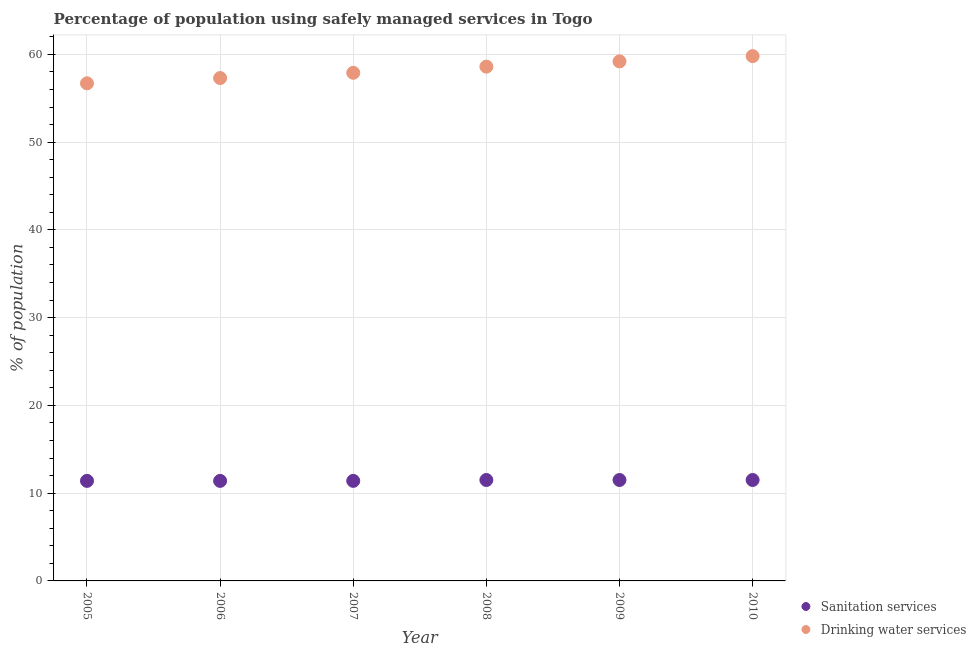Across all years, what is the minimum percentage of population who used drinking water services?
Ensure brevity in your answer.  56.7. In which year was the percentage of population who used sanitation services minimum?
Your response must be concise. 2005. What is the total percentage of population who used sanitation services in the graph?
Ensure brevity in your answer.  68.7. What is the difference between the percentage of population who used sanitation services in 2006 and that in 2009?
Keep it short and to the point. -0.1. What is the difference between the percentage of population who used sanitation services in 2010 and the percentage of population who used drinking water services in 2006?
Ensure brevity in your answer.  -45.8. What is the average percentage of population who used drinking water services per year?
Ensure brevity in your answer.  58.25. In the year 2009, what is the difference between the percentage of population who used sanitation services and percentage of population who used drinking water services?
Offer a terse response. -47.7. What is the ratio of the percentage of population who used sanitation services in 2009 to that in 2010?
Provide a short and direct response. 1. Is the percentage of population who used sanitation services in 2005 less than that in 2006?
Your answer should be compact. No. Is the difference between the percentage of population who used sanitation services in 2007 and 2009 greater than the difference between the percentage of population who used drinking water services in 2007 and 2009?
Your response must be concise. Yes. What is the difference between the highest and the second highest percentage of population who used drinking water services?
Your response must be concise. 0.6. What is the difference between the highest and the lowest percentage of population who used sanitation services?
Give a very brief answer. 0.1. In how many years, is the percentage of population who used sanitation services greater than the average percentage of population who used sanitation services taken over all years?
Your answer should be compact. 3. Does the percentage of population who used sanitation services monotonically increase over the years?
Keep it short and to the point. No. Is the percentage of population who used sanitation services strictly greater than the percentage of population who used drinking water services over the years?
Keep it short and to the point. No. What is the difference between two consecutive major ticks on the Y-axis?
Your answer should be compact. 10. Are the values on the major ticks of Y-axis written in scientific E-notation?
Provide a succinct answer. No. Does the graph contain grids?
Your answer should be compact. Yes. What is the title of the graph?
Ensure brevity in your answer.  Percentage of population using safely managed services in Togo. What is the label or title of the Y-axis?
Give a very brief answer. % of population. What is the % of population in Sanitation services in 2005?
Provide a succinct answer. 11.4. What is the % of population of Drinking water services in 2005?
Provide a short and direct response. 56.7. What is the % of population of Drinking water services in 2006?
Your response must be concise. 57.3. What is the % of population in Drinking water services in 2007?
Your answer should be compact. 57.9. What is the % of population in Drinking water services in 2008?
Keep it short and to the point. 58.6. What is the % of population in Sanitation services in 2009?
Provide a short and direct response. 11.5. What is the % of population in Drinking water services in 2009?
Your answer should be very brief. 59.2. What is the % of population of Sanitation services in 2010?
Give a very brief answer. 11.5. What is the % of population in Drinking water services in 2010?
Your answer should be compact. 59.8. Across all years, what is the maximum % of population of Sanitation services?
Give a very brief answer. 11.5. Across all years, what is the maximum % of population of Drinking water services?
Give a very brief answer. 59.8. Across all years, what is the minimum % of population in Sanitation services?
Your answer should be very brief. 11.4. Across all years, what is the minimum % of population in Drinking water services?
Ensure brevity in your answer.  56.7. What is the total % of population in Sanitation services in the graph?
Ensure brevity in your answer.  68.7. What is the total % of population in Drinking water services in the graph?
Your answer should be very brief. 349.5. What is the difference between the % of population in Sanitation services in 2005 and that in 2006?
Give a very brief answer. 0. What is the difference between the % of population in Drinking water services in 2005 and that in 2006?
Give a very brief answer. -0.6. What is the difference between the % of population of Sanitation services in 2005 and that in 2007?
Offer a very short reply. 0. What is the difference between the % of population in Drinking water services in 2005 and that in 2007?
Provide a short and direct response. -1.2. What is the difference between the % of population in Sanitation services in 2005 and that in 2008?
Your answer should be very brief. -0.1. What is the difference between the % of population in Drinking water services in 2005 and that in 2008?
Your answer should be very brief. -1.9. What is the difference between the % of population in Drinking water services in 2005 and that in 2009?
Give a very brief answer. -2.5. What is the difference between the % of population in Drinking water services in 2005 and that in 2010?
Your answer should be very brief. -3.1. What is the difference between the % of population of Sanitation services in 2006 and that in 2007?
Provide a succinct answer. 0. What is the difference between the % of population of Sanitation services in 2006 and that in 2009?
Offer a terse response. -0.1. What is the difference between the % of population in Drinking water services in 2006 and that in 2009?
Offer a terse response. -1.9. What is the difference between the % of population in Sanitation services in 2006 and that in 2010?
Your answer should be compact. -0.1. What is the difference between the % of population in Drinking water services in 2007 and that in 2008?
Your answer should be compact. -0.7. What is the difference between the % of population of Drinking water services in 2007 and that in 2009?
Your answer should be very brief. -1.3. What is the difference between the % of population in Sanitation services in 2007 and that in 2010?
Your answer should be compact. -0.1. What is the difference between the % of population in Drinking water services in 2007 and that in 2010?
Your answer should be very brief. -1.9. What is the difference between the % of population of Drinking water services in 2008 and that in 2009?
Keep it short and to the point. -0.6. What is the difference between the % of population of Sanitation services in 2009 and that in 2010?
Provide a succinct answer. 0. What is the difference between the % of population of Drinking water services in 2009 and that in 2010?
Ensure brevity in your answer.  -0.6. What is the difference between the % of population of Sanitation services in 2005 and the % of population of Drinking water services in 2006?
Your answer should be compact. -45.9. What is the difference between the % of population of Sanitation services in 2005 and the % of population of Drinking water services in 2007?
Provide a short and direct response. -46.5. What is the difference between the % of population of Sanitation services in 2005 and the % of population of Drinking water services in 2008?
Offer a terse response. -47.2. What is the difference between the % of population of Sanitation services in 2005 and the % of population of Drinking water services in 2009?
Make the answer very short. -47.8. What is the difference between the % of population of Sanitation services in 2005 and the % of population of Drinking water services in 2010?
Provide a succinct answer. -48.4. What is the difference between the % of population of Sanitation services in 2006 and the % of population of Drinking water services in 2007?
Offer a very short reply. -46.5. What is the difference between the % of population of Sanitation services in 2006 and the % of population of Drinking water services in 2008?
Ensure brevity in your answer.  -47.2. What is the difference between the % of population of Sanitation services in 2006 and the % of population of Drinking water services in 2009?
Your response must be concise. -47.8. What is the difference between the % of population of Sanitation services in 2006 and the % of population of Drinking water services in 2010?
Provide a succinct answer. -48.4. What is the difference between the % of population of Sanitation services in 2007 and the % of population of Drinking water services in 2008?
Offer a terse response. -47.2. What is the difference between the % of population of Sanitation services in 2007 and the % of population of Drinking water services in 2009?
Keep it short and to the point. -47.8. What is the difference between the % of population of Sanitation services in 2007 and the % of population of Drinking water services in 2010?
Provide a short and direct response. -48.4. What is the difference between the % of population of Sanitation services in 2008 and the % of population of Drinking water services in 2009?
Your answer should be very brief. -47.7. What is the difference between the % of population in Sanitation services in 2008 and the % of population in Drinking water services in 2010?
Make the answer very short. -48.3. What is the difference between the % of population of Sanitation services in 2009 and the % of population of Drinking water services in 2010?
Your response must be concise. -48.3. What is the average % of population in Sanitation services per year?
Keep it short and to the point. 11.45. What is the average % of population in Drinking water services per year?
Offer a very short reply. 58.25. In the year 2005, what is the difference between the % of population in Sanitation services and % of population in Drinking water services?
Make the answer very short. -45.3. In the year 2006, what is the difference between the % of population in Sanitation services and % of population in Drinking water services?
Your answer should be compact. -45.9. In the year 2007, what is the difference between the % of population in Sanitation services and % of population in Drinking water services?
Ensure brevity in your answer.  -46.5. In the year 2008, what is the difference between the % of population of Sanitation services and % of population of Drinking water services?
Ensure brevity in your answer.  -47.1. In the year 2009, what is the difference between the % of population of Sanitation services and % of population of Drinking water services?
Offer a terse response. -47.7. In the year 2010, what is the difference between the % of population in Sanitation services and % of population in Drinking water services?
Your answer should be very brief. -48.3. What is the ratio of the % of population in Sanitation services in 2005 to that in 2006?
Give a very brief answer. 1. What is the ratio of the % of population of Drinking water services in 2005 to that in 2006?
Your response must be concise. 0.99. What is the ratio of the % of population of Sanitation services in 2005 to that in 2007?
Offer a very short reply. 1. What is the ratio of the % of population of Drinking water services in 2005 to that in 2007?
Your answer should be compact. 0.98. What is the ratio of the % of population of Sanitation services in 2005 to that in 2008?
Ensure brevity in your answer.  0.99. What is the ratio of the % of population of Drinking water services in 2005 to that in 2008?
Make the answer very short. 0.97. What is the ratio of the % of population in Drinking water services in 2005 to that in 2009?
Keep it short and to the point. 0.96. What is the ratio of the % of population in Drinking water services in 2005 to that in 2010?
Provide a succinct answer. 0.95. What is the ratio of the % of population of Sanitation services in 2006 to that in 2008?
Keep it short and to the point. 0.99. What is the ratio of the % of population in Drinking water services in 2006 to that in 2008?
Give a very brief answer. 0.98. What is the ratio of the % of population in Drinking water services in 2006 to that in 2009?
Your answer should be compact. 0.97. What is the ratio of the % of population in Sanitation services in 2006 to that in 2010?
Your answer should be compact. 0.99. What is the ratio of the % of population of Drinking water services in 2006 to that in 2010?
Offer a terse response. 0.96. What is the ratio of the % of population in Sanitation services in 2007 to that in 2008?
Your response must be concise. 0.99. What is the ratio of the % of population in Drinking water services in 2007 to that in 2008?
Provide a short and direct response. 0.99. What is the ratio of the % of population of Drinking water services in 2007 to that in 2009?
Provide a short and direct response. 0.98. What is the ratio of the % of population in Sanitation services in 2007 to that in 2010?
Your response must be concise. 0.99. What is the ratio of the % of population of Drinking water services in 2007 to that in 2010?
Provide a succinct answer. 0.97. What is the ratio of the % of population in Sanitation services in 2008 to that in 2009?
Give a very brief answer. 1. What is the ratio of the % of population in Drinking water services in 2008 to that in 2009?
Offer a terse response. 0.99. What is the ratio of the % of population in Drinking water services in 2008 to that in 2010?
Ensure brevity in your answer.  0.98. What is the ratio of the % of population of Sanitation services in 2009 to that in 2010?
Give a very brief answer. 1. What is the ratio of the % of population in Drinking water services in 2009 to that in 2010?
Ensure brevity in your answer.  0.99. What is the difference between the highest and the second highest % of population of Sanitation services?
Your answer should be compact. 0. What is the difference between the highest and the second highest % of population in Drinking water services?
Keep it short and to the point. 0.6. What is the difference between the highest and the lowest % of population in Drinking water services?
Provide a succinct answer. 3.1. 